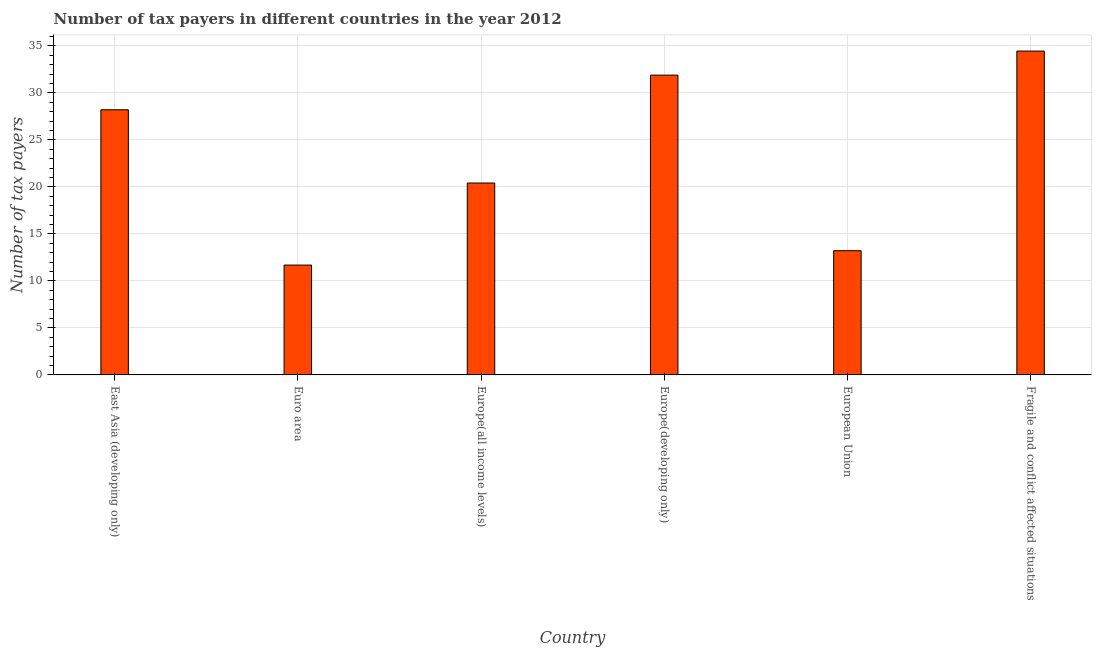Does the graph contain grids?
Your answer should be very brief. Yes. What is the title of the graph?
Your answer should be very brief. Number of tax payers in different countries in the year 2012. What is the label or title of the Y-axis?
Keep it short and to the point. Number of tax payers. What is the number of tax payers in Europe(all income levels)?
Make the answer very short. 20.42. Across all countries, what is the maximum number of tax payers?
Provide a short and direct response. 34.45. Across all countries, what is the minimum number of tax payers?
Provide a short and direct response. 11.68. In which country was the number of tax payers maximum?
Ensure brevity in your answer.  Fragile and conflict affected situations. What is the sum of the number of tax payers?
Give a very brief answer. 139.87. What is the difference between the number of tax payers in Europe(all income levels) and European Union?
Provide a succinct answer. 7.2. What is the average number of tax payers per country?
Your answer should be compact. 23.31. What is the median number of tax payers?
Your answer should be very brief. 24.31. In how many countries, is the number of tax payers greater than 11 ?
Offer a very short reply. 6. What is the ratio of the number of tax payers in Euro area to that in Europe(all income levels)?
Give a very brief answer. 0.57. Is the difference between the number of tax payers in Europe(all income levels) and Fragile and conflict affected situations greater than the difference between any two countries?
Make the answer very short. No. What is the difference between the highest and the second highest number of tax payers?
Provide a succinct answer. 2.56. What is the difference between the highest and the lowest number of tax payers?
Your response must be concise. 22.77. What is the Number of tax payers of East Asia (developing only)?
Offer a very short reply. 28.21. What is the Number of tax payers of Euro area?
Make the answer very short. 11.68. What is the Number of tax payers of Europe(all income levels)?
Give a very brief answer. 20.42. What is the Number of tax payers of Europe(developing only)?
Offer a terse response. 31.89. What is the Number of tax payers in European Union?
Your response must be concise. 13.21. What is the Number of tax payers of Fragile and conflict affected situations?
Give a very brief answer. 34.45. What is the difference between the Number of tax payers in East Asia (developing only) and Euro area?
Make the answer very short. 16.53. What is the difference between the Number of tax payers in East Asia (developing only) and Europe(all income levels)?
Keep it short and to the point. 7.79. What is the difference between the Number of tax payers in East Asia (developing only) and Europe(developing only)?
Offer a terse response. -3.68. What is the difference between the Number of tax payers in East Asia (developing only) and European Union?
Your answer should be very brief. 15. What is the difference between the Number of tax payers in East Asia (developing only) and Fragile and conflict affected situations?
Ensure brevity in your answer.  -6.24. What is the difference between the Number of tax payers in Euro area and Europe(all income levels)?
Your answer should be very brief. -8.73. What is the difference between the Number of tax payers in Euro area and Europe(developing only)?
Keep it short and to the point. -20.21. What is the difference between the Number of tax payers in Euro area and European Union?
Your answer should be compact. -1.53. What is the difference between the Number of tax payers in Euro area and Fragile and conflict affected situations?
Your answer should be compact. -22.77. What is the difference between the Number of tax payers in Europe(all income levels) and Europe(developing only)?
Your answer should be compact. -11.48. What is the difference between the Number of tax payers in Europe(all income levels) and European Union?
Your response must be concise. 7.2. What is the difference between the Number of tax payers in Europe(all income levels) and Fragile and conflict affected situations?
Provide a succinct answer. -14.04. What is the difference between the Number of tax payers in Europe(developing only) and European Union?
Make the answer very short. 18.68. What is the difference between the Number of tax payers in Europe(developing only) and Fragile and conflict affected situations?
Your response must be concise. -2.56. What is the difference between the Number of tax payers in European Union and Fragile and conflict affected situations?
Your response must be concise. -21.24. What is the ratio of the Number of tax payers in East Asia (developing only) to that in Euro area?
Give a very brief answer. 2.41. What is the ratio of the Number of tax payers in East Asia (developing only) to that in Europe(all income levels)?
Make the answer very short. 1.38. What is the ratio of the Number of tax payers in East Asia (developing only) to that in Europe(developing only)?
Your answer should be compact. 0.88. What is the ratio of the Number of tax payers in East Asia (developing only) to that in European Union?
Provide a short and direct response. 2.13. What is the ratio of the Number of tax payers in East Asia (developing only) to that in Fragile and conflict affected situations?
Your answer should be compact. 0.82. What is the ratio of the Number of tax payers in Euro area to that in Europe(all income levels)?
Give a very brief answer. 0.57. What is the ratio of the Number of tax payers in Euro area to that in Europe(developing only)?
Provide a short and direct response. 0.37. What is the ratio of the Number of tax payers in Euro area to that in European Union?
Provide a short and direct response. 0.88. What is the ratio of the Number of tax payers in Euro area to that in Fragile and conflict affected situations?
Your response must be concise. 0.34. What is the ratio of the Number of tax payers in Europe(all income levels) to that in Europe(developing only)?
Provide a short and direct response. 0.64. What is the ratio of the Number of tax payers in Europe(all income levels) to that in European Union?
Provide a succinct answer. 1.54. What is the ratio of the Number of tax payers in Europe(all income levels) to that in Fragile and conflict affected situations?
Ensure brevity in your answer.  0.59. What is the ratio of the Number of tax payers in Europe(developing only) to that in European Union?
Offer a very short reply. 2.41. What is the ratio of the Number of tax payers in Europe(developing only) to that in Fragile and conflict affected situations?
Your answer should be very brief. 0.93. What is the ratio of the Number of tax payers in European Union to that in Fragile and conflict affected situations?
Offer a terse response. 0.38. 